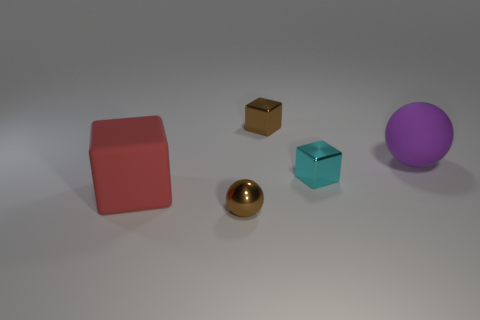Subtract all metal cubes. How many cubes are left? 1 Add 1 large brown spheres. How many objects exist? 6 Subtract all purple balls. How many balls are left? 1 Add 4 red cubes. How many red cubes exist? 5 Subtract 1 cyan cubes. How many objects are left? 4 Subtract all balls. How many objects are left? 3 Subtract 1 blocks. How many blocks are left? 2 Subtract all purple blocks. Subtract all purple cylinders. How many blocks are left? 3 Subtract all yellow balls. How many yellow blocks are left? 0 Subtract all large purple rubber spheres. Subtract all large purple matte objects. How many objects are left? 3 